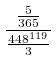Convert formula to latex. <formula><loc_0><loc_0><loc_500><loc_500>\frac { \frac { 5 } { 3 6 5 } } { \frac { 4 4 8 ^ { 1 1 9 } } { 3 } }</formula> 